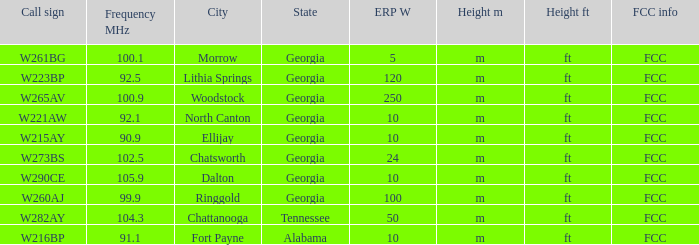What is the lowest ERP W of  w223bp? 120.0. 